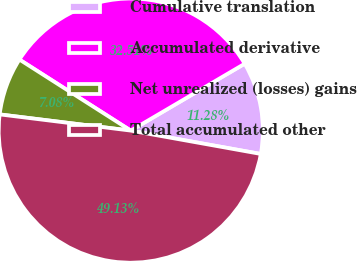Convert chart to OTSL. <chart><loc_0><loc_0><loc_500><loc_500><pie_chart><fcel>Cumulative translation<fcel>Accumulated derivative<fcel>Net unrealized (losses) gains<fcel>Total accumulated other<nl><fcel>11.28%<fcel>32.51%<fcel>7.08%<fcel>49.13%<nl></chart> 